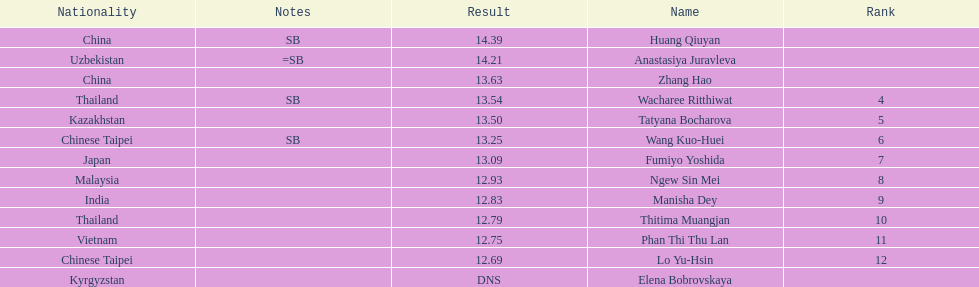How many competitors had less than 13.00 points? 6. 